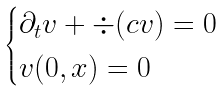<formula> <loc_0><loc_0><loc_500><loc_500>\begin{cases} \partial _ { t } v + \div ( c v ) = 0 \\ v ( 0 , x ) = 0 \end{cases}</formula> 